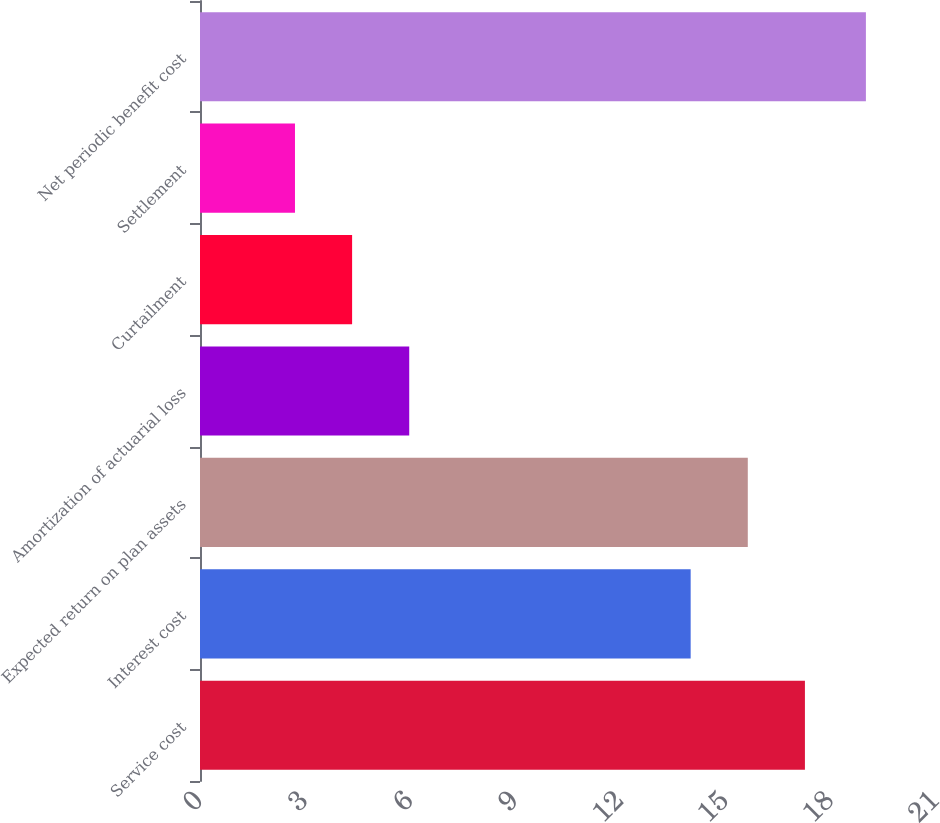Convert chart to OTSL. <chart><loc_0><loc_0><loc_500><loc_500><bar_chart><fcel>Service cost<fcel>Interest cost<fcel>Expected return on plan assets<fcel>Amortization of actuarial loss<fcel>Curtailment<fcel>Settlement<fcel>Net periodic benefit cost<nl><fcel>17.26<fcel>14<fcel>15.63<fcel>5.97<fcel>4.34<fcel>2.71<fcel>19<nl></chart> 